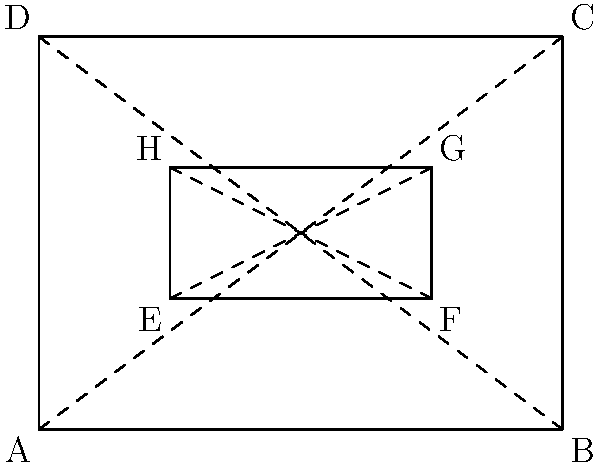In the diagram above, ABCD represents the outline of a saddle tree, and EFGH represents the seat area. If the area of ABCD is 12 square units, what is the area of EFGH in square units? To solve this problem, we'll follow these steps:

1. Recognize that ABCD and EFGH are both rectangles.
2. Calculate the dimensions of ABCD:
   - Width (AB) = 4 units
   - Height (AD) = 3 units
3. Calculate the area of ABCD:
   $Area_{ABCD} = 4 \times 3 = 12$ square units (given)
4. Observe that EFGH is similar to ABCD, but smaller.
5. Calculate the dimensions of EFGH:
   - Width (EF) = 2 units (half of AB)
   - Height (EH) = 1 unit (one-third of AD)
6. Calculate the area of EFGH:
   $Area_{EFGH} = 2 \times 1 = 2$ square units
7. Verify the relationship between the areas:
   $\frac{Area_{EFGH}}{Area_{ABCD}} = \frac{2}{12} = \frac{1}{6}$

This confirms that the seat area (EFGH) is one-sixth of the total saddle tree area (ABCD).
Answer: 2 square units 